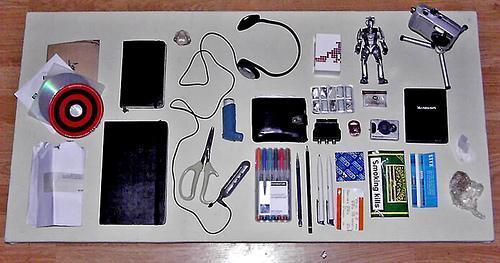How many cats are in this picture?
Give a very brief answer. 0. 